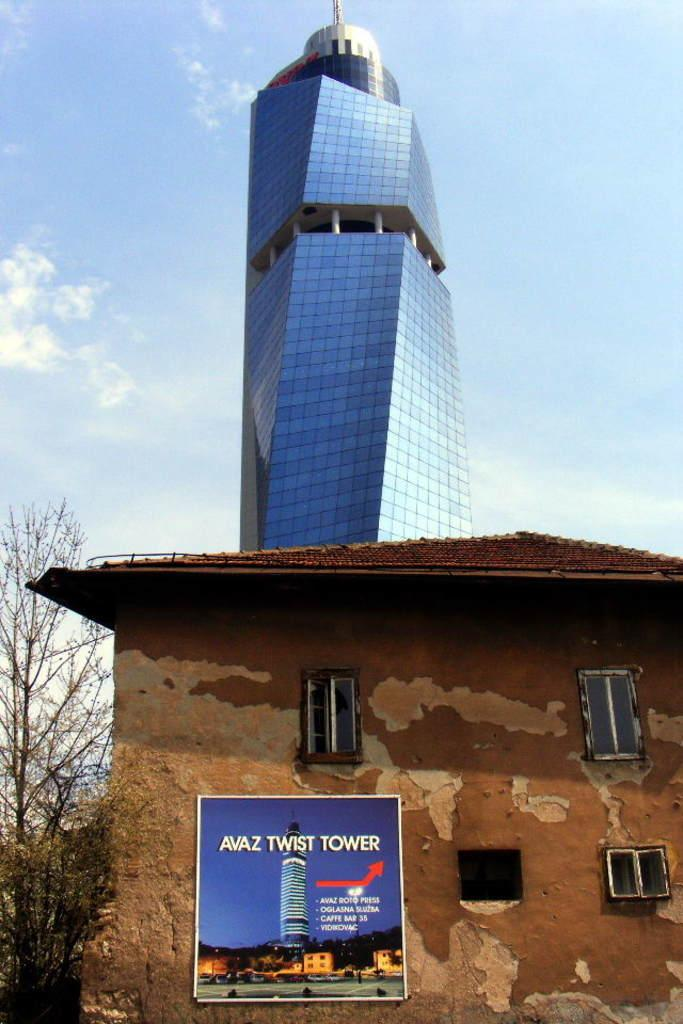What type of structure is located in the foreground of the image? There is a small house in the foreground of the image. What type of structure is located in the background of the image? There is a big building in the background of the image. What is visible in the background of the image? The sky is visible in the background of the image. How many eyes can be seen on the small house in the image? There are no eyes present on the small house in the image, as it is a structure and not a living being. 